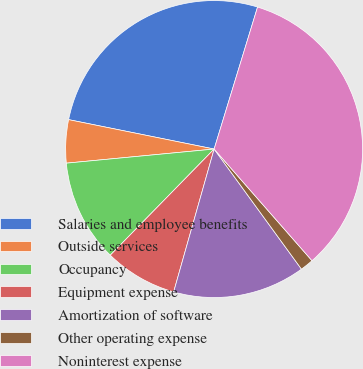Convert chart to OTSL. <chart><loc_0><loc_0><loc_500><loc_500><pie_chart><fcel>Salaries and employee benefits<fcel>Outside services<fcel>Occupancy<fcel>Equipment expense<fcel>Amortization of software<fcel>Other operating expense<fcel>Noninterest expense<nl><fcel>26.55%<fcel>4.69%<fcel>11.16%<fcel>7.93%<fcel>14.4%<fcel>1.45%<fcel>33.82%<nl></chart> 